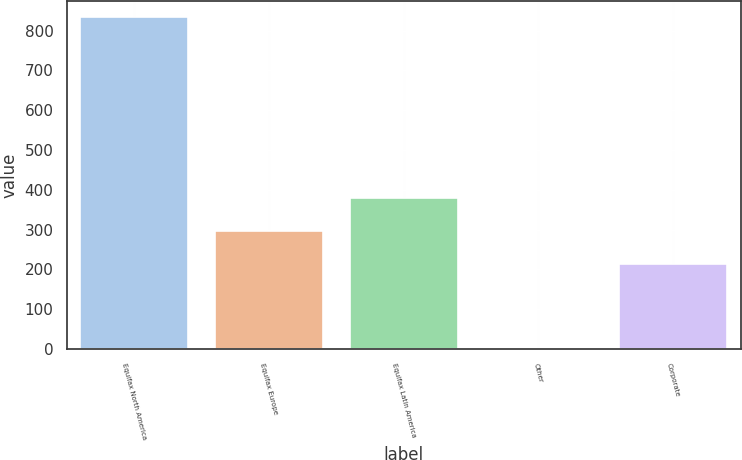Convert chart to OTSL. <chart><loc_0><loc_0><loc_500><loc_500><bar_chart><fcel>Equifax North America<fcel>Equifax Europe<fcel>Equifax Latin America<fcel>Other<fcel>Corporate<nl><fcel>832.9<fcel>296.5<fcel>379.5<fcel>2.9<fcel>213.5<nl></chart> 